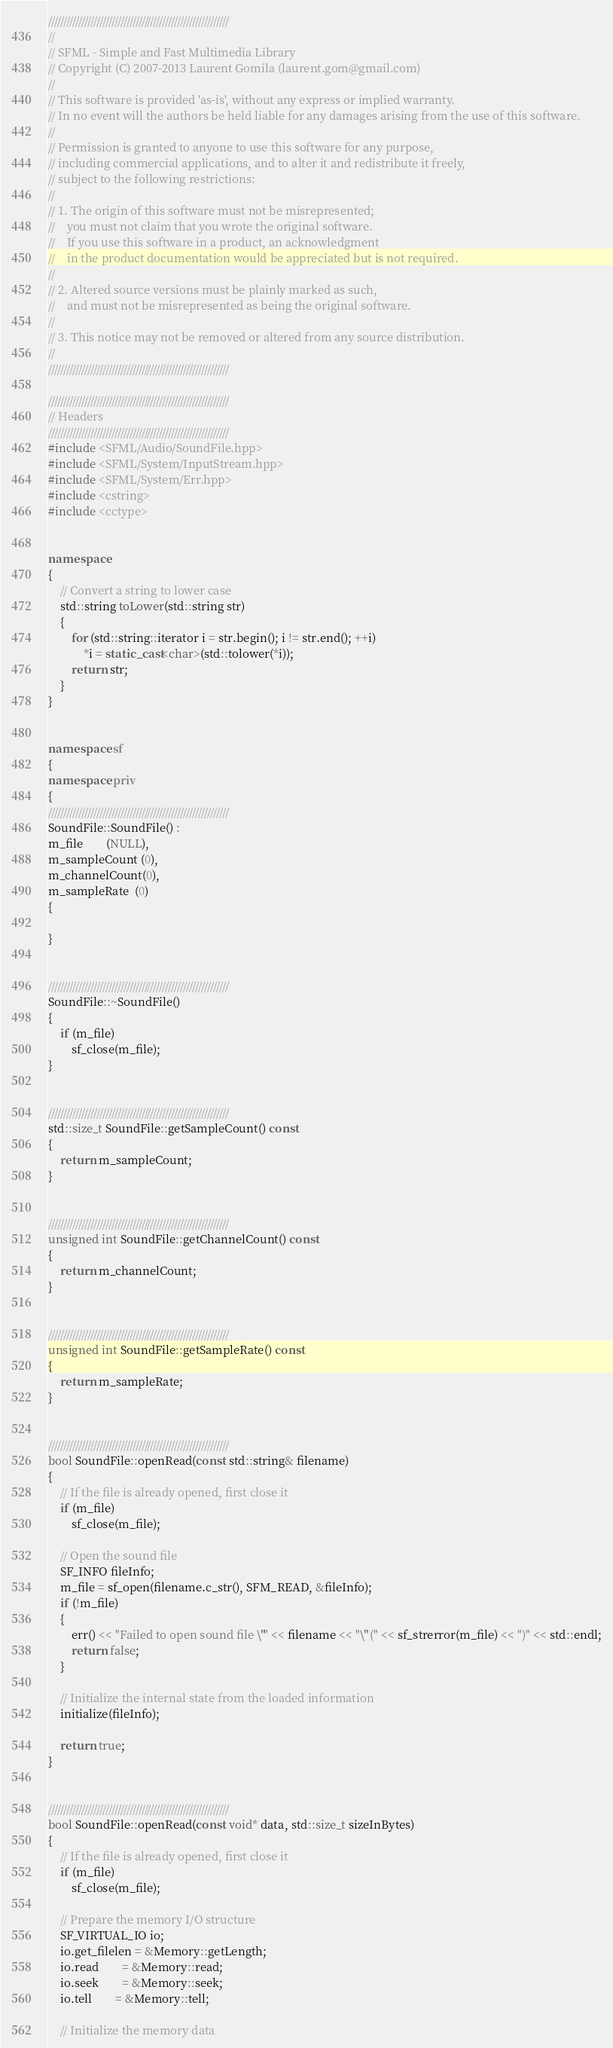<code> <loc_0><loc_0><loc_500><loc_500><_C++_>////////////////////////////////////////////////////////////
//
// SFML - Simple and Fast Multimedia Library
// Copyright (C) 2007-2013 Laurent Gomila (laurent.gom@gmail.com)
//
// This software is provided 'as-is', without any express or implied warranty.
// In no event will the authors be held liable for any damages arising from the use of this software.
//
// Permission is granted to anyone to use this software for any purpose,
// including commercial applications, and to alter it and redistribute it freely,
// subject to the following restrictions:
//
// 1. The origin of this software must not be misrepresented;
//    you must not claim that you wrote the original software.
//    If you use this software in a product, an acknowledgment
//    in the product documentation would be appreciated but is not required.
//
// 2. Altered source versions must be plainly marked as such,
//    and must not be misrepresented as being the original software.
//
// 3. This notice may not be removed or altered from any source distribution.
//
////////////////////////////////////////////////////////////

////////////////////////////////////////////////////////////
// Headers
////////////////////////////////////////////////////////////
#include <SFML/Audio/SoundFile.hpp>
#include <SFML/System/InputStream.hpp>
#include <SFML/System/Err.hpp>
#include <cstring>
#include <cctype>


namespace
{
    // Convert a string to lower case
    std::string toLower(std::string str)
    {
        for (std::string::iterator i = str.begin(); i != str.end(); ++i)
            *i = static_cast<char>(std::tolower(*i));
        return str;
    }
}


namespace sf
{
namespace priv
{
////////////////////////////////////////////////////////////
SoundFile::SoundFile() :
m_file        (NULL),
m_sampleCount (0),
m_channelCount(0),
m_sampleRate  (0)
{

}


////////////////////////////////////////////////////////////
SoundFile::~SoundFile()
{
    if (m_file)
        sf_close(m_file);
}


////////////////////////////////////////////////////////////
std::size_t SoundFile::getSampleCount() const
{
    return m_sampleCount;
}


////////////////////////////////////////////////////////////
unsigned int SoundFile::getChannelCount() const
{
    return m_channelCount;
}


////////////////////////////////////////////////////////////
unsigned int SoundFile::getSampleRate() const
{
    return m_sampleRate;
}


////////////////////////////////////////////////////////////
bool SoundFile::openRead(const std::string& filename)
{
    // If the file is already opened, first close it
    if (m_file)
        sf_close(m_file);

    // Open the sound file
    SF_INFO fileInfo;
    m_file = sf_open(filename.c_str(), SFM_READ, &fileInfo);
    if (!m_file)
    {
        err() << "Failed to open sound file \"" << filename << "\" (" << sf_strerror(m_file) << ")" << std::endl;
        return false;
    }

    // Initialize the internal state from the loaded information
    initialize(fileInfo);

    return true;
}


////////////////////////////////////////////////////////////
bool SoundFile::openRead(const void* data, std::size_t sizeInBytes)
{
    // If the file is already opened, first close it
    if (m_file)
        sf_close(m_file);

    // Prepare the memory I/O structure
    SF_VIRTUAL_IO io;
    io.get_filelen = &Memory::getLength;
    io.read        = &Memory::read;
    io.seek        = &Memory::seek;
    io.tell        = &Memory::tell;

    // Initialize the memory data</code> 